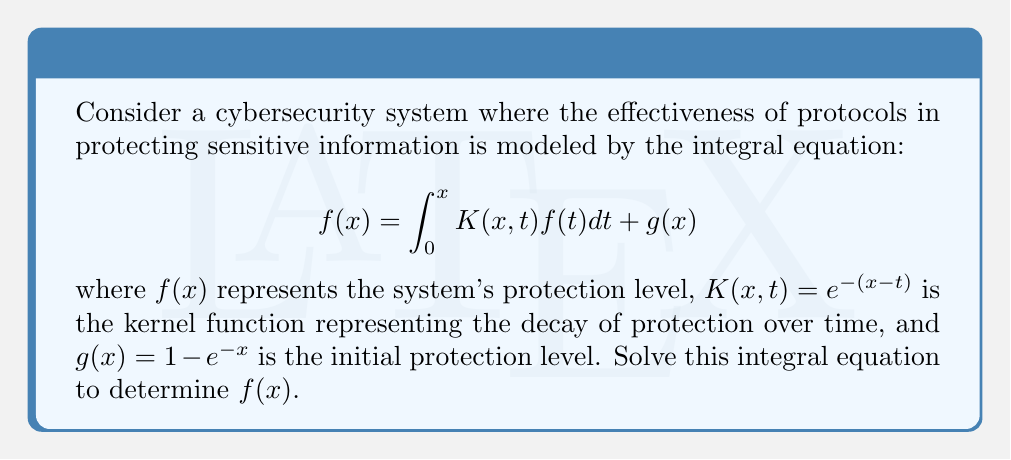Show me your answer to this math problem. To solve this integral equation, we'll follow these steps:

1) First, differentiate both sides of the equation with respect to $x$:

   $$f'(x) = K(x,x)f(x) + \int_0^x \frac{\partial K(x,t)}{\partial x}f(t)dt + g'(x)$$

2) Substitute the given functions:

   $$f'(x) = e^0f(x) + \int_0^x (-e^{-(x-t)})f(t)dt + e^{-x}$$

3) Simplify:

   $$f'(x) = f(x) - \int_0^x e^{-(x-t)}f(t)dt + e^{-x}$$

4) Differentiate again:

   $$f''(x) = f'(x) - e^{-(x-x)}f(x) + \int_0^x e^{-(x-t)}f(t)dt - e^{-x}$$

5) Simplify and substitute the integral from step 3:

   $$f''(x) = f'(x) - f(x) + (f'(x) - f(x) + e^{-x}) - e^{-x}$$

6) Simplify further:

   $$f''(x) = 2f'(x) - 2f(x)$$

7) This is a second-order linear differential equation. The characteristic equation is:

   $$r^2 - 2r + 2 = 0$$

8) Solve the characteristic equation:

   $$r = 1 \pm i$$

9) The general solution is:

   $$f(x) = e^x(c_1\cos x + c_2\sin x)$$

10) To find $c_1$ and $c_2$, use the initial conditions:

    $$f(0) = g(0) = 0$$
    $$f'(0) = g'(0) = 1$$

11) Applying these conditions:

    $$c_1 = 0$$
    $$c_2 = 1$$

Therefore, the solution is:

$$f(x) = e^x\sin x$$
Answer: $f(x) = e^x\sin x$ 